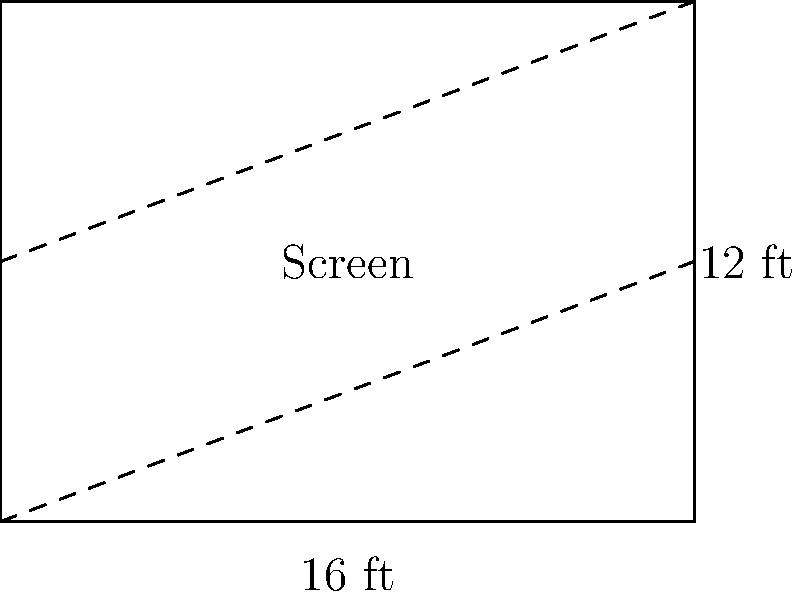For the lunchtime seminars, you need to determine the area of a rectangular presentation screen. The screen has a width of 16 feet and a height of 12 feet. What is the area of the screen in square feet? To find the area of a rectangular screen, we need to multiply its width by its height.

Given:
- Width of the screen = 16 feet
- Height of the screen = 12 feet

Step 1: Apply the formula for the area of a rectangle.
Area = Width × Height

Step 2: Substitute the known values into the formula.
Area = 16 ft × 12 ft

Step 3: Perform the multiplication.
Area = 192 ft²

Therefore, the area of the presentation screen is 192 square feet.
Answer: 192 ft² 